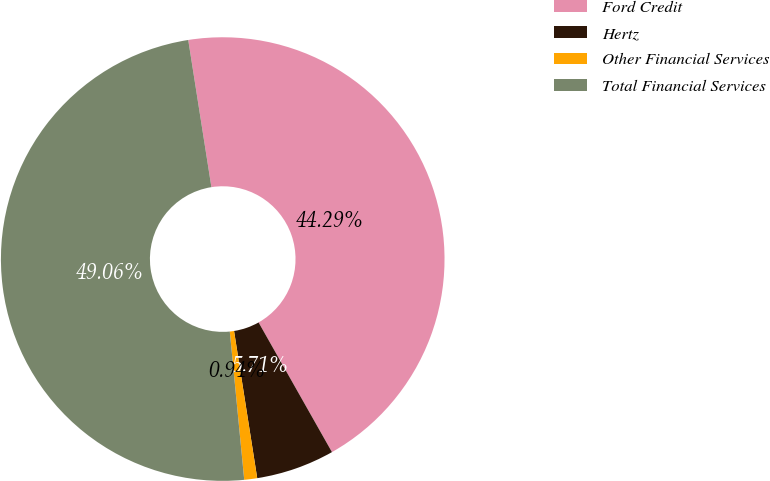Convert chart to OTSL. <chart><loc_0><loc_0><loc_500><loc_500><pie_chart><fcel>Ford Credit<fcel>Hertz<fcel>Other Financial Services<fcel>Total Financial Services<nl><fcel>44.29%<fcel>5.71%<fcel>0.94%<fcel>49.06%<nl></chart> 